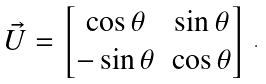<formula> <loc_0><loc_0><loc_500><loc_500>\begin{array} { l l l } \vec { U } = \begin{bmatrix} \cos \theta & \sin \theta \\ - \sin \theta & \cos \theta \end{bmatrix} \end{array} .</formula> 